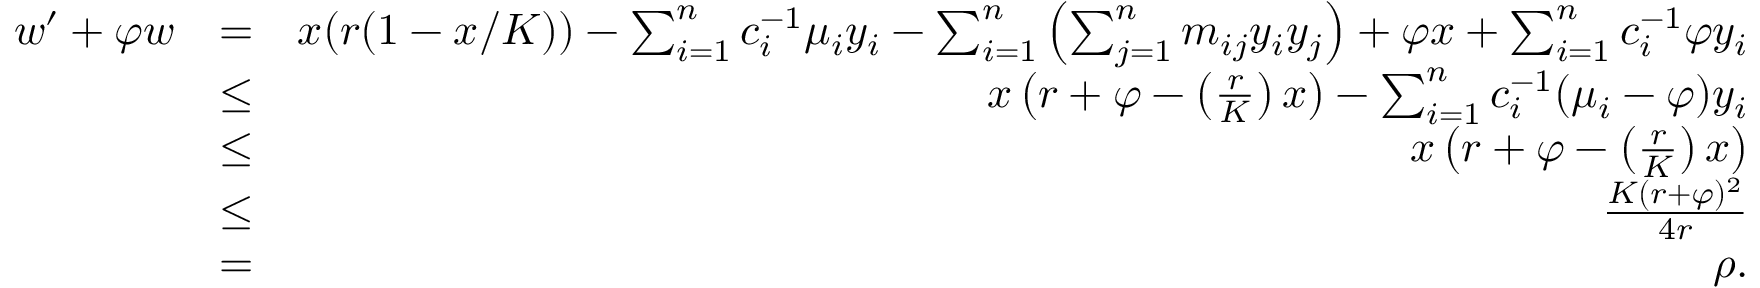Convert formula to latex. <formula><loc_0><loc_0><loc_500><loc_500>\begin{array} { r l r } { w ^ { \prime } + \varphi w } & { = } & { x ( r ( 1 - x / K ) ) - \sum _ { i = 1 } ^ { n } c _ { i } ^ { - 1 } \mu _ { i } y _ { i } - \sum _ { i = 1 } ^ { n } \left ( \sum _ { j = 1 } ^ { n } m _ { i j } y _ { i } y _ { j } \right ) + \varphi x + \sum _ { i = 1 } ^ { n } c _ { i } ^ { - 1 } \varphi y _ { i } } \\ & { \leq } & { x \left ( r + \varphi - \left ( \frac { r } { K } \right ) x \right ) - \sum _ { i = 1 } ^ { n } c _ { i } ^ { - 1 } ( \mu _ { i } - \varphi ) y _ { i } } \\ & { \leq } & { x \left ( r + \varphi - \left ( \frac { r } { K } \right ) x \right ) } \\ & { \leq } & { \frac { K ( r + \varphi ) ^ { 2 } } { 4 r } } \\ & { = } & { \rho . } \end{array}</formula> 